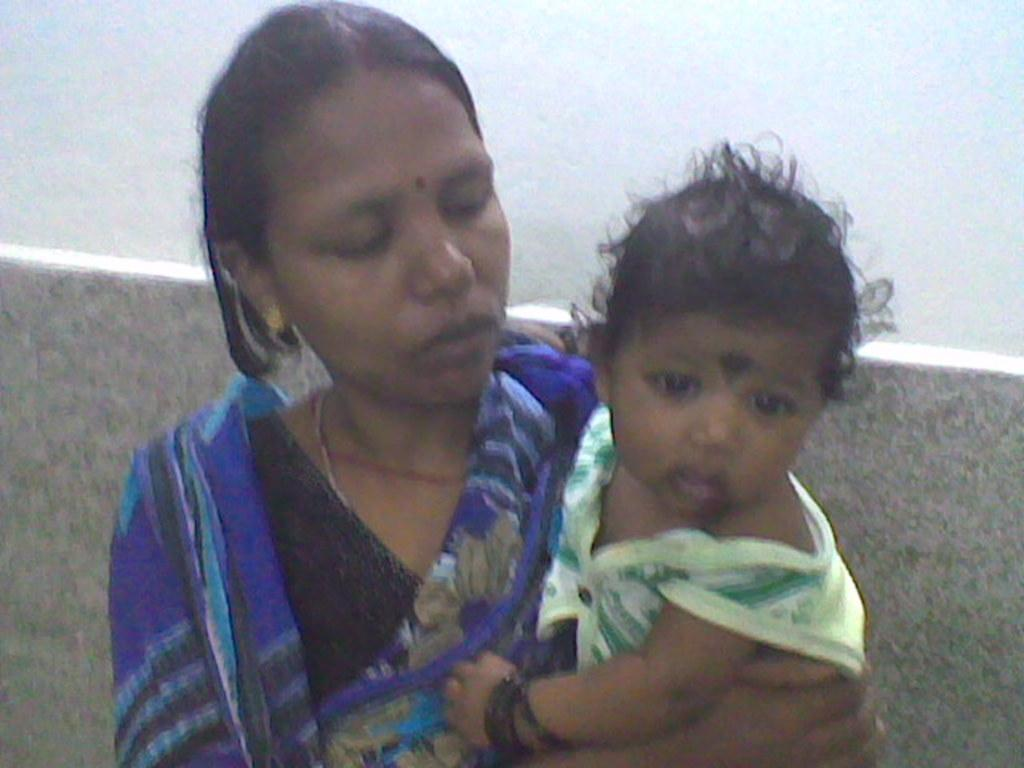Who is present in the image? There is a woman in the image. What is the woman holding? The woman is holding a baby. What type of building can be seen in the background of the image? There is no building present in the image; it only features a woman holding a baby. 